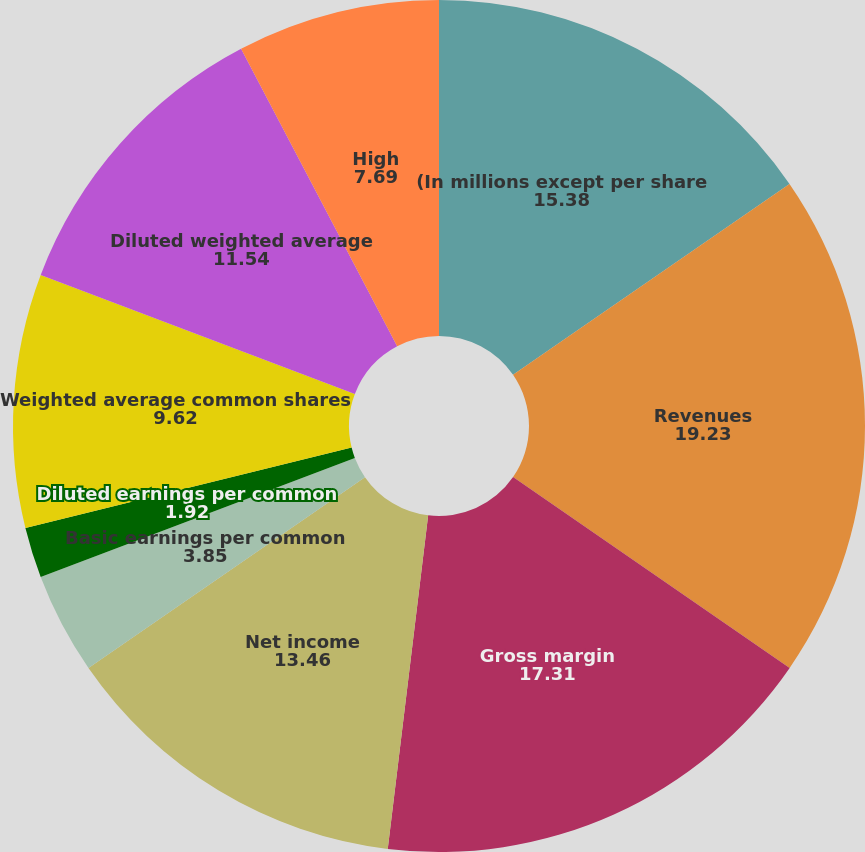<chart> <loc_0><loc_0><loc_500><loc_500><pie_chart><fcel>(In millions except per share<fcel>Revenues<fcel>Gross margin<fcel>Net income<fcel>Basic earnings per common<fcel>Diluted earnings per common<fcel>Weighted average common shares<fcel>Diluted weighted average<fcel>Cash dividends declared per<fcel>High<nl><fcel>15.38%<fcel>19.23%<fcel>17.31%<fcel>13.46%<fcel>3.85%<fcel>1.92%<fcel>9.62%<fcel>11.54%<fcel>0.0%<fcel>7.69%<nl></chart> 